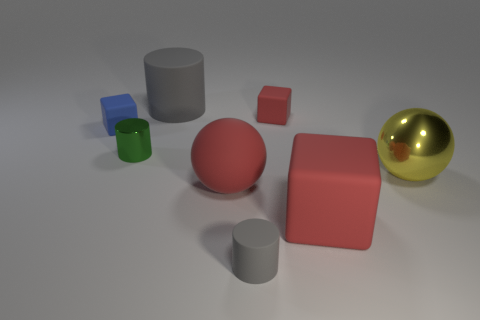What number of other things are there of the same color as the large matte cylinder?
Offer a very short reply. 1. How many big things are both left of the yellow object and in front of the tiny shiny cylinder?
Your answer should be very brief. 2. The tiny green metal thing is what shape?
Make the answer very short. Cylinder. What number of other things are there of the same material as the small red cube
Offer a very short reply. 5. What color is the large cylinder that is behind the sphere that is to the right of the big red object that is right of the tiny matte cylinder?
Your answer should be very brief. Gray. What material is the green thing that is the same size as the blue matte cube?
Your answer should be very brief. Metal. What number of things are either big metallic objects right of the small gray matte cylinder or red matte cubes?
Your answer should be very brief. 3. Is there a big cyan rubber ball?
Offer a very short reply. No. What is the material of the big ball left of the tiny gray cylinder?
Give a very brief answer. Rubber. What number of tiny objects are either brown shiny cylinders or yellow shiny objects?
Provide a short and direct response. 0. 